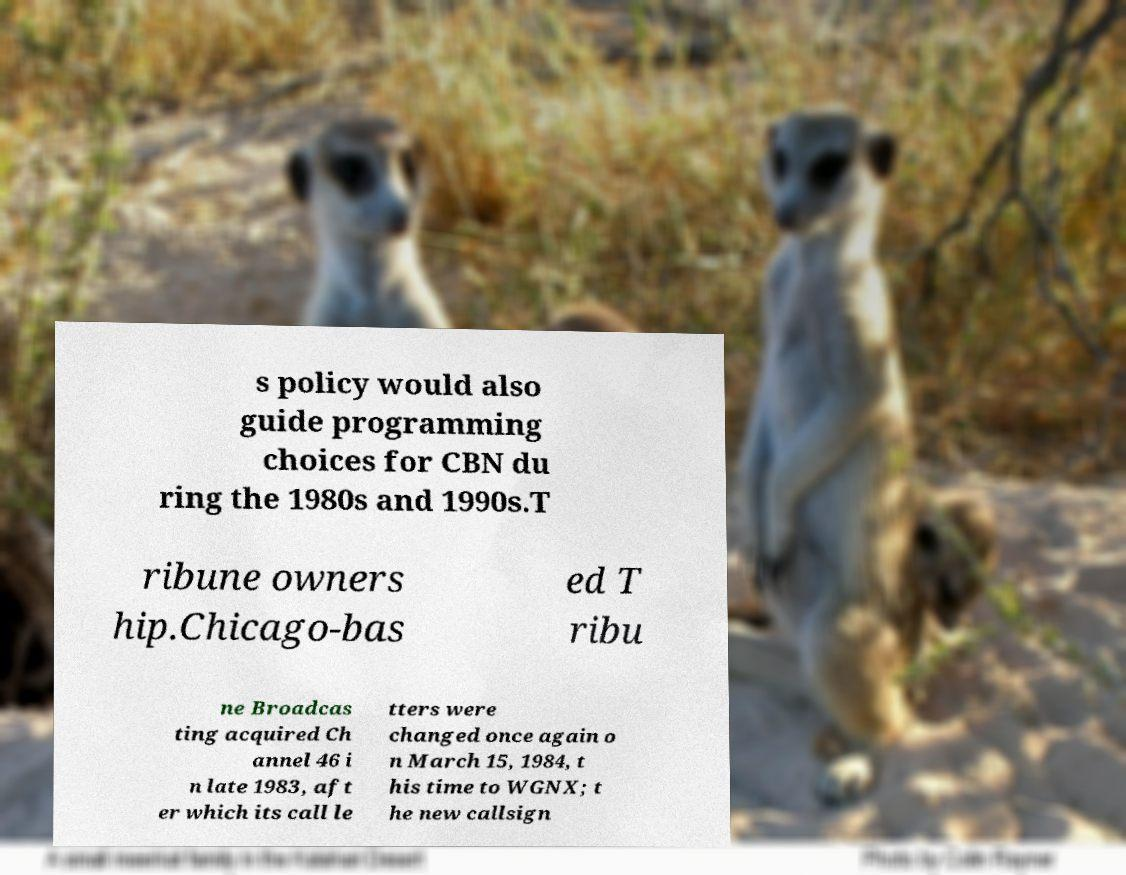Could you extract and type out the text from this image? s policy would also guide programming choices for CBN du ring the 1980s and 1990s.T ribune owners hip.Chicago-bas ed T ribu ne Broadcas ting acquired Ch annel 46 i n late 1983, aft er which its call le tters were changed once again o n March 15, 1984, t his time to WGNX; t he new callsign 